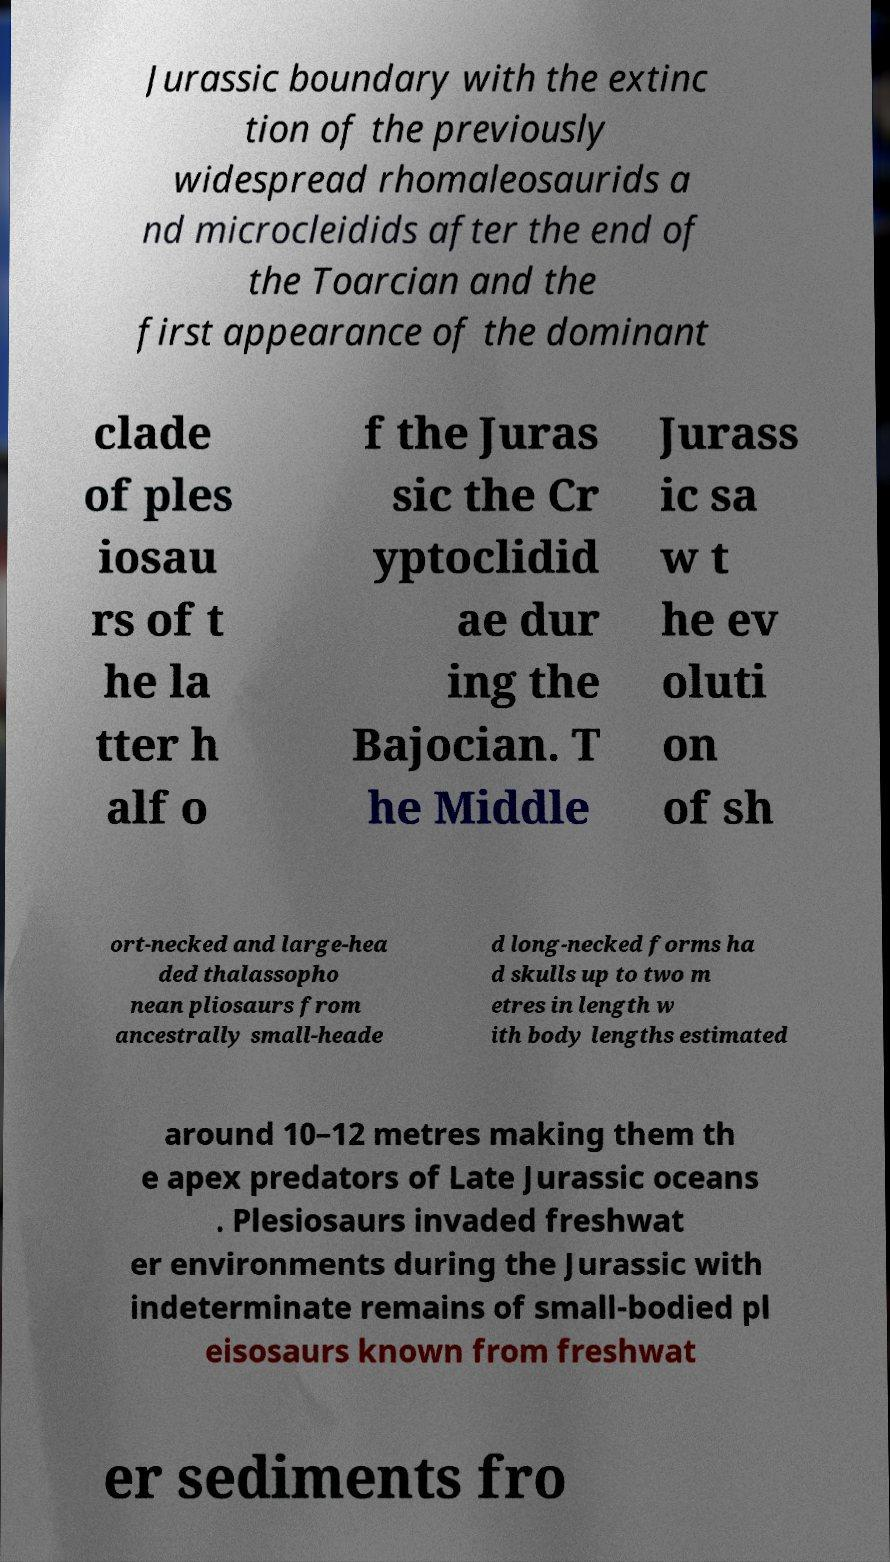Please identify and transcribe the text found in this image. Jurassic boundary with the extinc tion of the previously widespread rhomaleosaurids a nd microcleidids after the end of the Toarcian and the first appearance of the dominant clade of ples iosau rs of t he la tter h alf o f the Juras sic the Cr yptoclidid ae dur ing the Bajocian. T he Middle Jurass ic sa w t he ev oluti on of sh ort-necked and large-hea ded thalassopho nean pliosaurs from ancestrally small-heade d long-necked forms ha d skulls up to two m etres in length w ith body lengths estimated around 10–12 metres making them th e apex predators of Late Jurassic oceans . Plesiosaurs invaded freshwat er environments during the Jurassic with indeterminate remains of small-bodied pl eisosaurs known from freshwat er sediments fro 